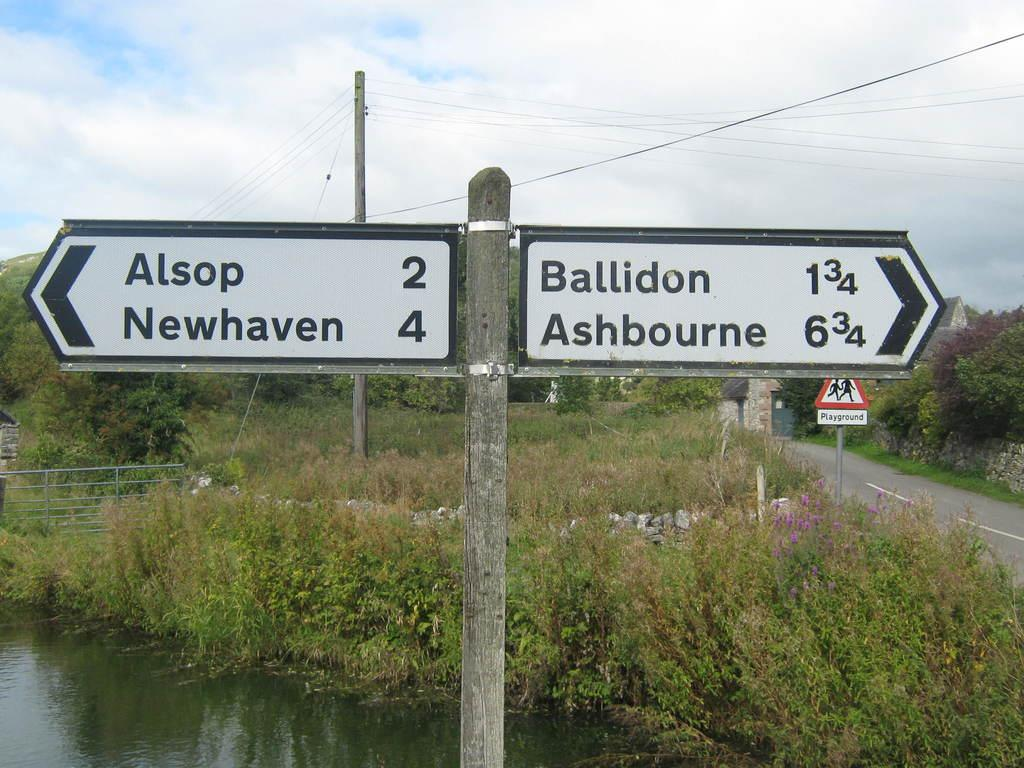Provide a one-sentence caption for the provided image. A scene in the country side showing a cross roads sign giving the distance to several towns including Ballidon. 